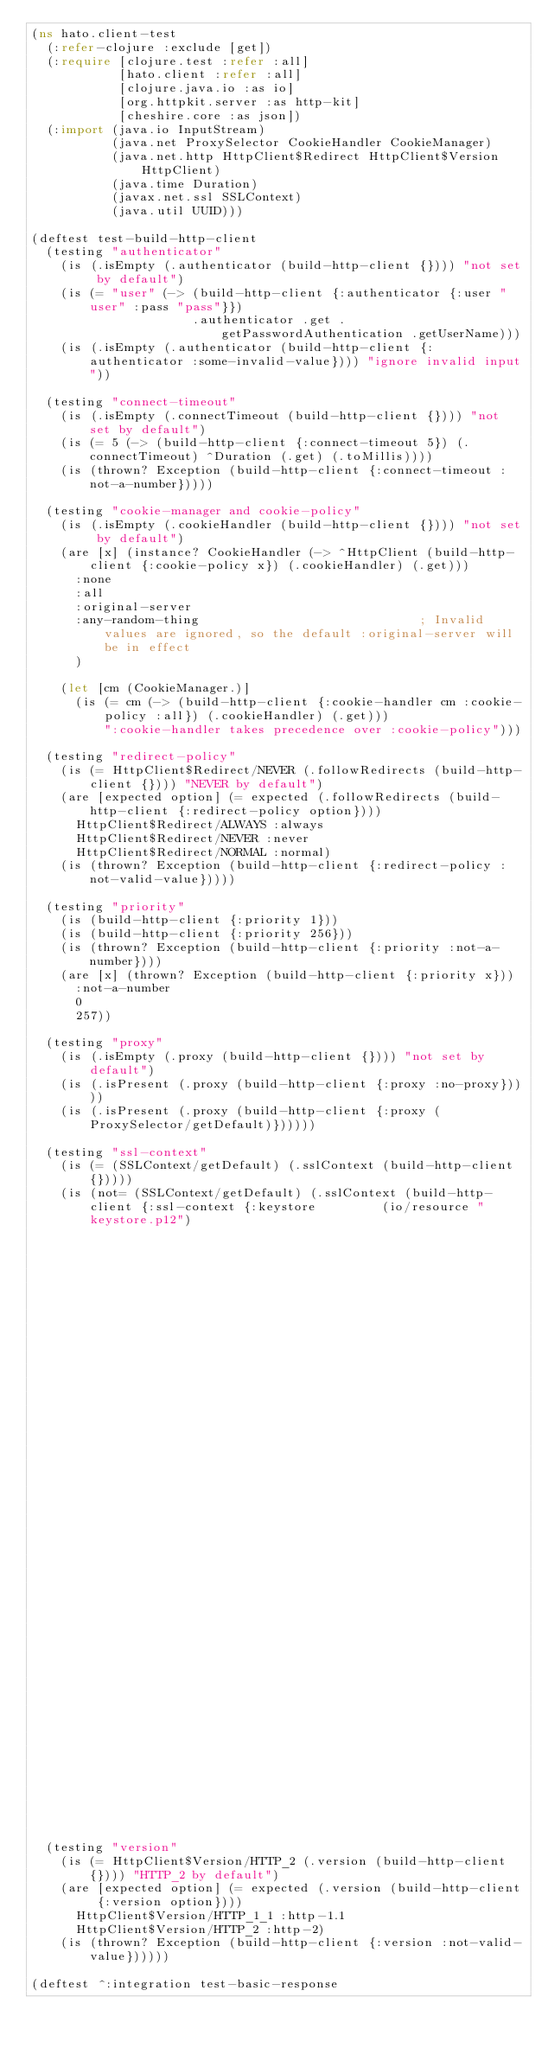Convert code to text. <code><loc_0><loc_0><loc_500><loc_500><_Clojure_>(ns hato.client-test
  (:refer-clojure :exclude [get])
  (:require [clojure.test :refer :all]
            [hato.client :refer :all]
            [clojure.java.io :as io]
            [org.httpkit.server :as http-kit]
            [cheshire.core :as json])
  (:import (java.io InputStream)
           (java.net ProxySelector CookieHandler CookieManager)
           (java.net.http HttpClient$Redirect HttpClient$Version HttpClient)
           (java.time Duration)
           (javax.net.ssl SSLContext)
           (java.util UUID)))

(deftest test-build-http-client
  (testing "authenticator"
    (is (.isEmpty (.authenticator (build-http-client {}))) "not set by default")
    (is (= "user" (-> (build-http-client {:authenticator {:user "user" :pass "pass"}})
                      .authenticator .get .getPasswordAuthentication .getUserName)))
    (is (.isEmpty (.authenticator (build-http-client {:authenticator :some-invalid-value}))) "ignore invalid input"))

  (testing "connect-timeout"
    (is (.isEmpty (.connectTimeout (build-http-client {}))) "not set by default")
    (is (= 5 (-> (build-http-client {:connect-timeout 5}) (.connectTimeout) ^Duration (.get) (.toMillis))))
    (is (thrown? Exception (build-http-client {:connect-timeout :not-a-number}))))

  (testing "cookie-manager and cookie-policy"
    (is (.isEmpty (.cookieHandler (build-http-client {}))) "not set by default")
    (are [x] (instance? CookieHandler (-> ^HttpClient (build-http-client {:cookie-policy x}) (.cookieHandler) (.get)))
      :none
      :all
      :original-server
      :any-random-thing                              ; Invalid values are ignored, so the default :original-server will be in effect
      )

    (let [cm (CookieManager.)]
      (is (= cm (-> (build-http-client {:cookie-handler cm :cookie-policy :all}) (.cookieHandler) (.get)))
          ":cookie-handler takes precedence over :cookie-policy")))

  (testing "redirect-policy"
    (is (= HttpClient$Redirect/NEVER (.followRedirects (build-http-client {}))) "NEVER by default")
    (are [expected option] (= expected (.followRedirects (build-http-client {:redirect-policy option})))
      HttpClient$Redirect/ALWAYS :always
      HttpClient$Redirect/NEVER :never
      HttpClient$Redirect/NORMAL :normal)
    (is (thrown? Exception (build-http-client {:redirect-policy :not-valid-value}))))

  (testing "priority"
    (is (build-http-client {:priority 1}))
    (is (build-http-client {:priority 256}))
    (is (thrown? Exception (build-http-client {:priority :not-a-number})))
    (are [x] (thrown? Exception (build-http-client {:priority x}))
      :not-a-number
      0
      257))

  (testing "proxy"
    (is (.isEmpty (.proxy (build-http-client {}))) "not set by default")
    (is (.isPresent (.proxy (build-http-client {:proxy :no-proxy}))))
    (is (.isPresent (.proxy (build-http-client {:proxy (ProxySelector/getDefault)})))))

  (testing "ssl-context"
    (is (= (SSLContext/getDefault) (.sslContext (build-http-client {}))))
    (is (not= (SSLContext/getDefault) (.sslContext (build-http-client {:ssl-context {:keystore         (io/resource "keystore.p12")
                                                                                     :keystore-pass    "borisman"
                                                                                     :trust-store      (io/resource "keystore.p12")
                                                                                     :trust-store-pass "borisman"}})))))

  (testing "version"
    (is (= HttpClient$Version/HTTP_2 (.version (build-http-client {}))) "HTTP_2 by default")
    (are [expected option] (= expected (.version (build-http-client {:version option})))
      HttpClient$Version/HTTP_1_1 :http-1.1
      HttpClient$Version/HTTP_2 :http-2)
    (is (thrown? Exception (build-http-client {:version :not-valid-value})))))

(deftest ^:integration test-basic-response</code> 